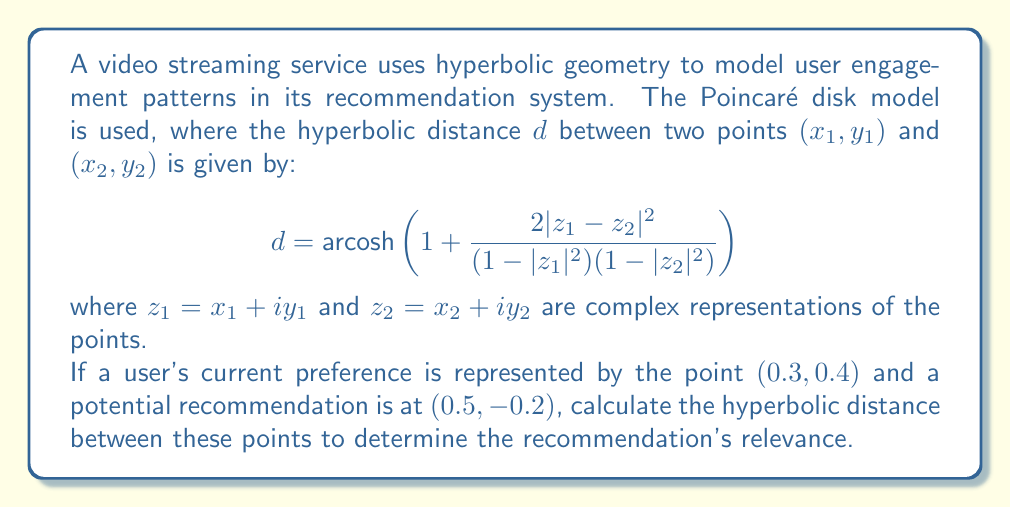Can you solve this math problem? To solve this problem, we'll follow these steps:

1) First, let's identify our points:
   $z_1 = 0.3 + 0.4i$
   $z_2 = 0.5 - 0.2i$

2) Calculate $|z_1|^2$ and $|z_2|^2$:
   $|z_1|^2 = 0.3^2 + 0.4^2 = 0.09 + 0.16 = 0.25$
   $|z_2|^2 = 0.5^2 + (-0.2)^2 = 0.25 + 0.04 = 0.29$

3) Calculate $|z_1 - z_2|^2$:
   $z_1 - z_2 = (0.3 + 0.4i) - (0.5 - 0.2i) = -0.2 + 0.6i$
   $|z_1 - z_2|^2 = (-0.2)^2 + 0.6^2 = 0.04 + 0.36 = 0.4$

4) Now, let's plug these values into our formula:

   $$d = \text{arcosh}\left(1 + \frac{2(0.4)}{(1-0.25)(1-0.29)}\right)$$

5) Simplify:
   $$d = \text{arcosh}\left(1 + \frac{0.8}{(0.75)(0.71)}\right)$$
   $$d = \text{arcosh}\left(1 + \frac{0.8}{0.5325}\right)$$
   $$d = \text{arcosh}(2.5023)$$

6) Calculate the final result:
   $$d \approx 1.5677$$

This hyperbolic distance represents the relevance of the recommendation to the user's current preference in the hyperbolic space of the recommendation system.
Answer: $1.5677$ 